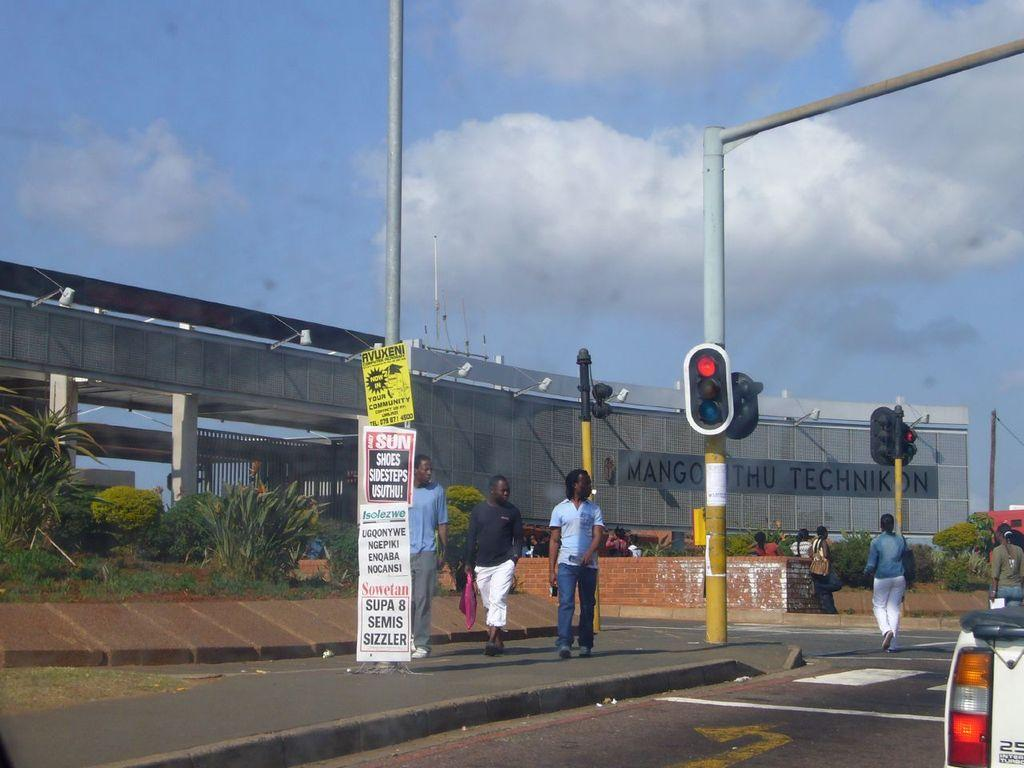<image>
Write a terse but informative summary of the picture. Street with a sign that says Shoes Sidesteps on it. 